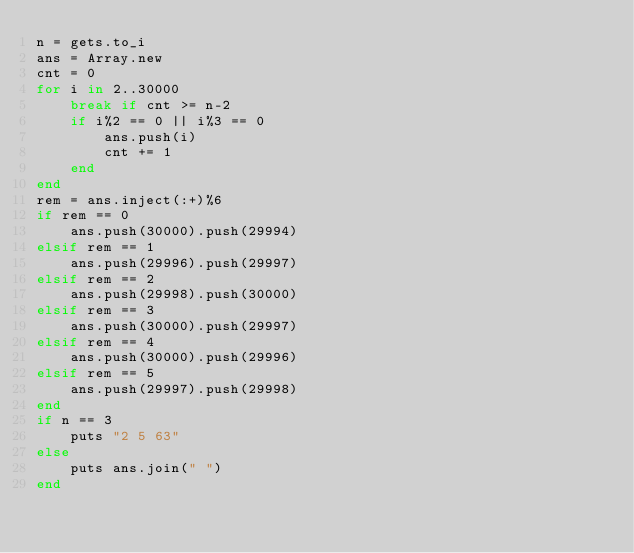Convert code to text. <code><loc_0><loc_0><loc_500><loc_500><_Ruby_>n = gets.to_i
ans = Array.new
cnt = 0
for i in 2..30000
    break if cnt >= n-2
    if i%2 == 0 || i%3 == 0
        ans.push(i)
        cnt += 1
    end
end
rem = ans.inject(:+)%6
if rem == 0
    ans.push(30000).push(29994)
elsif rem == 1
    ans.push(29996).push(29997)
elsif rem == 2
    ans.push(29998).push(30000)
elsif rem == 3
    ans.push(30000).push(29997)
elsif rem == 4
    ans.push(30000).push(29996)
elsif rem == 5
    ans.push(29997).push(29998)
end
if n == 3
    puts "2 5 63"
else
    puts ans.join(" ")
end</code> 